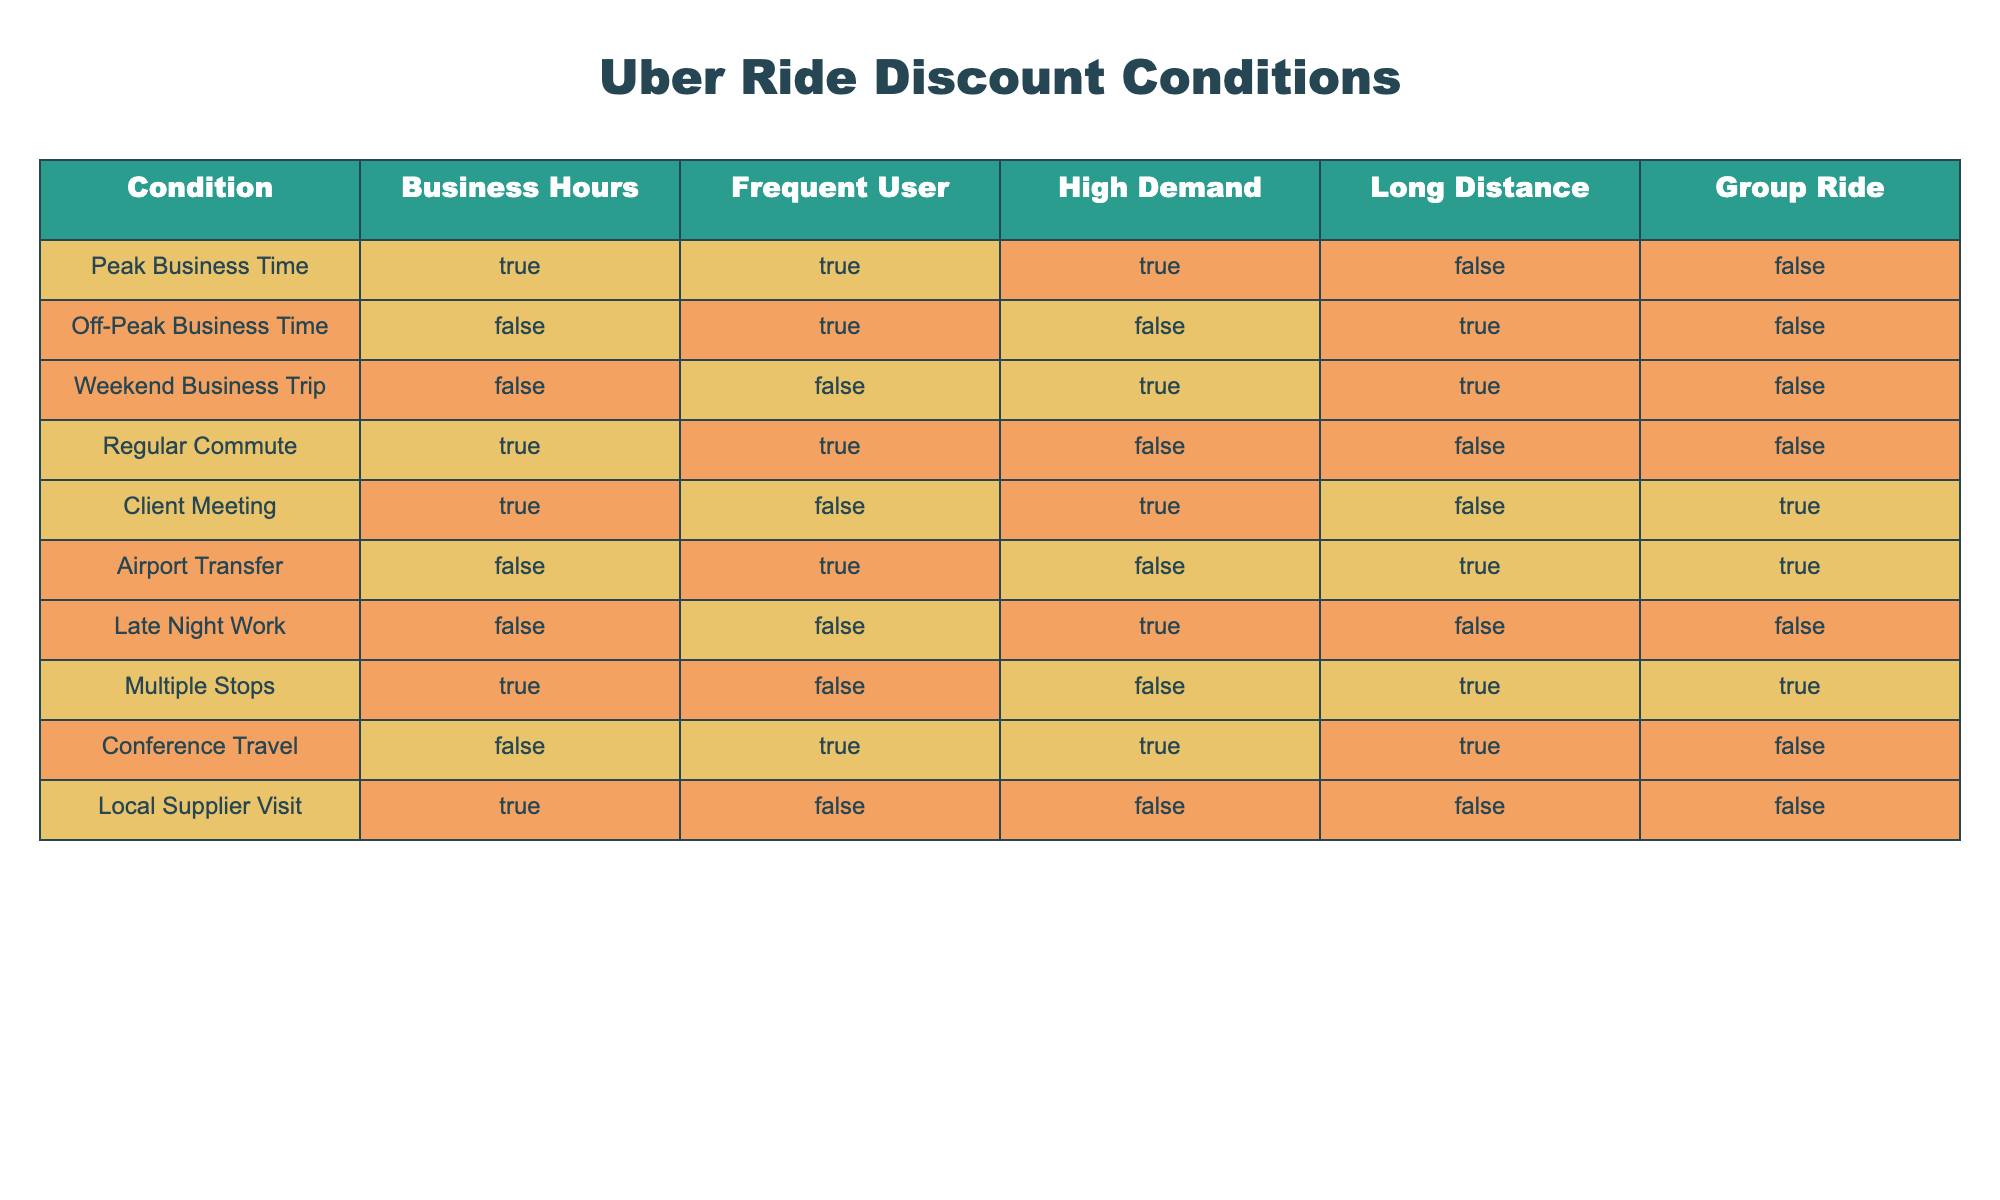What rides are eligible for discounts during peak business hours? According to the table, the rides eligible for discounts during peak business hours are: "Peak Business Time", "Regular Commute", and "Client Meeting".
Answer: Peak Business Time, Regular Commute, Client Meeting Is a group ride offered during a "Client Meeting"? The table shows that for "Client Meeting", the Group Ride condition is true. Hence, a group ride is offered during this time.
Answer: Yes How many situations allow for frequent user discounts without being in high demand? In the table, the situations where Frequent User is true and High Demand is false are "Regular Commute" and "Local Supplier Visit". This totals to two situations.
Answer: 2 Are there any weekends that qualify for ride discounts? The row "Weekend Business Trip" suggests that it is indeed on a weekend, but conditions for a discount also depend on the trip being categorized as high demand, which it is. Therefore, weekends do qualify for discounts.
Answer: Yes What is the condition where the ride is long distance but not during business hours? The "Airport Transfer" and "Off-Peak Business Time" conditions have a false value for Business Hours while being long distance. Thus, these are the conditions that fit this description.
Answer: Airport Transfer, Off-Peak Business Time How many conditions involve both frequent user and long-distance criteria combined? The conditions that meet both are “Airport Transfer”, “Weekend Business Trip”, and “Conference Travel”. Counting these shows a total of three conditions that meet both criteria.
Answer: 3 What is the total number of conditions under which there are no discounts applicable? The conditions with both false values for discounts are: "Off-Peak Business Time", "Late Night Work", and "Local Supplier Visit", which totals three conditions with no discounts.
Answer: 3 Are discounts available for rides to a local supplier visit during business hours? The "Local Supplier Visit" row shows that it occurs during business hours but has no conditions for discounts, thus confirming that discounts are not available in this situation.
Answer: No 